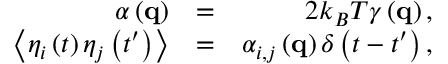<formula> <loc_0><loc_0><loc_500><loc_500>\begin{array} { r l r } { \alpha \left ( { q } \right ) } & { = } & { 2 k _ { B } T \gamma \left ( { q } \right ) , } \\ { \left \langle { { \eta _ { i } } \left ( t \right ) { \eta _ { j } } \left ( { t ^ { \prime } } \right ) } \right \rangle } & { = } & { { \alpha _ { i , j } } \left ( { q } \right ) \delta \left ( { t - t ^ { \prime } } \right ) , } \end{array}</formula> 